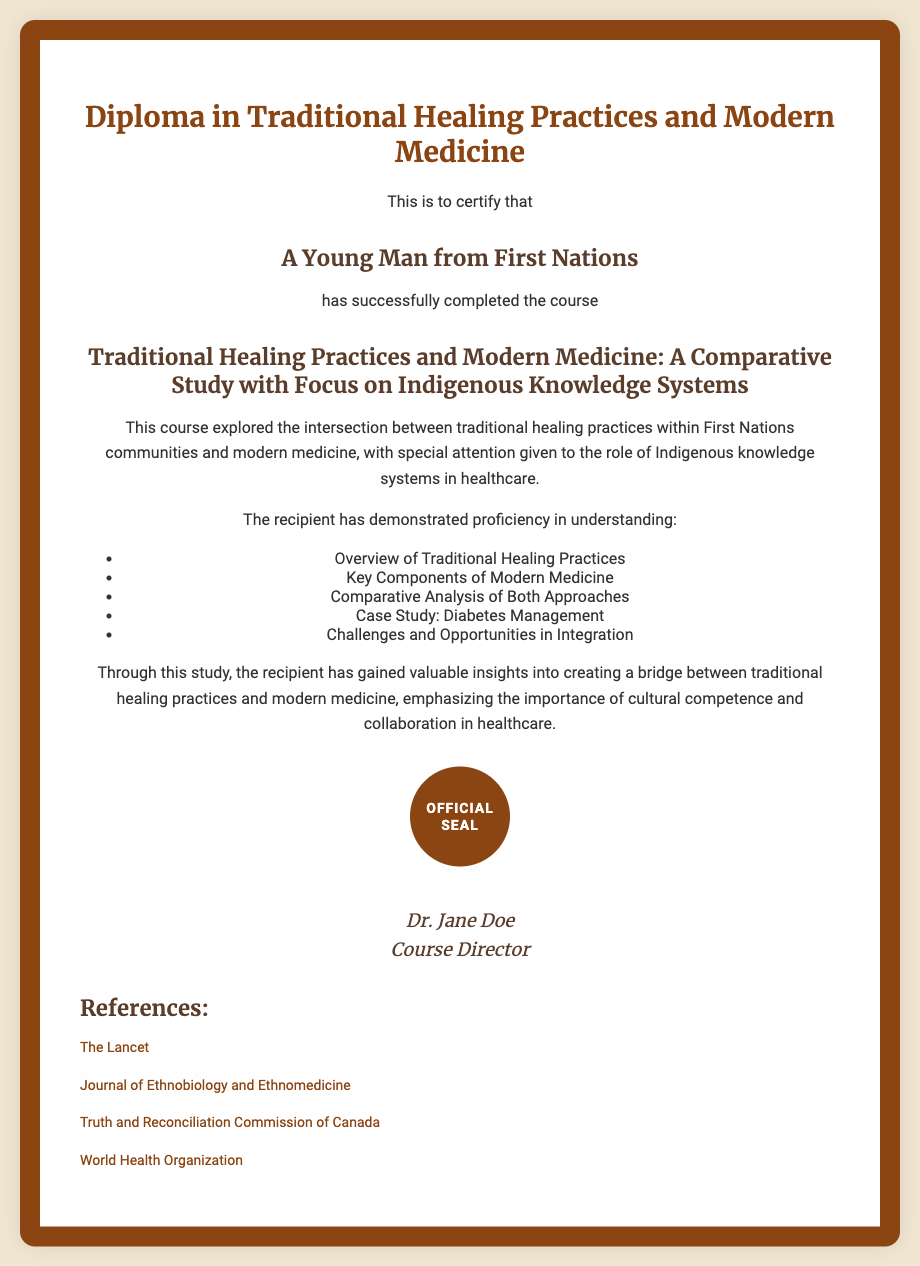what is the title of the diploma? The title of the diploma is clearly stated at the top of the document.
Answer: Diploma in Traditional Healing Practices and Modern Medicine who is the recipient of the diploma? The document specifies the name of the recipient prominently.
Answer: A Young Man from First Nations who is the course director? The signature section at the bottom of the document lists the name of the course director.
Answer: Dr. Jane Doe what is one key component covered in the course? The document lists several components covered in the course.
Answer: Key Components of Modern Medicine what case study is mentioned in the course? The course content includes a specific case study as part of the curriculum.
Answer: Diabetes Management what is the main purpose of the course? The document describes the overall purpose and focus of the course.
Answer: Creating a bridge between traditional healing practices and modern medicine how many references are listed in the document? The references section at the end indicates how many sources are cited.
Answer: Four which organization is mentioned in the references? The references include prominent organizations relevant to health and medicine.
Answer: World Health Organization what aspect of healing does the course emphasize? The document highlights a key focus area of the learning experience.
Answer: Cultural competence and collaboration in healthcare 